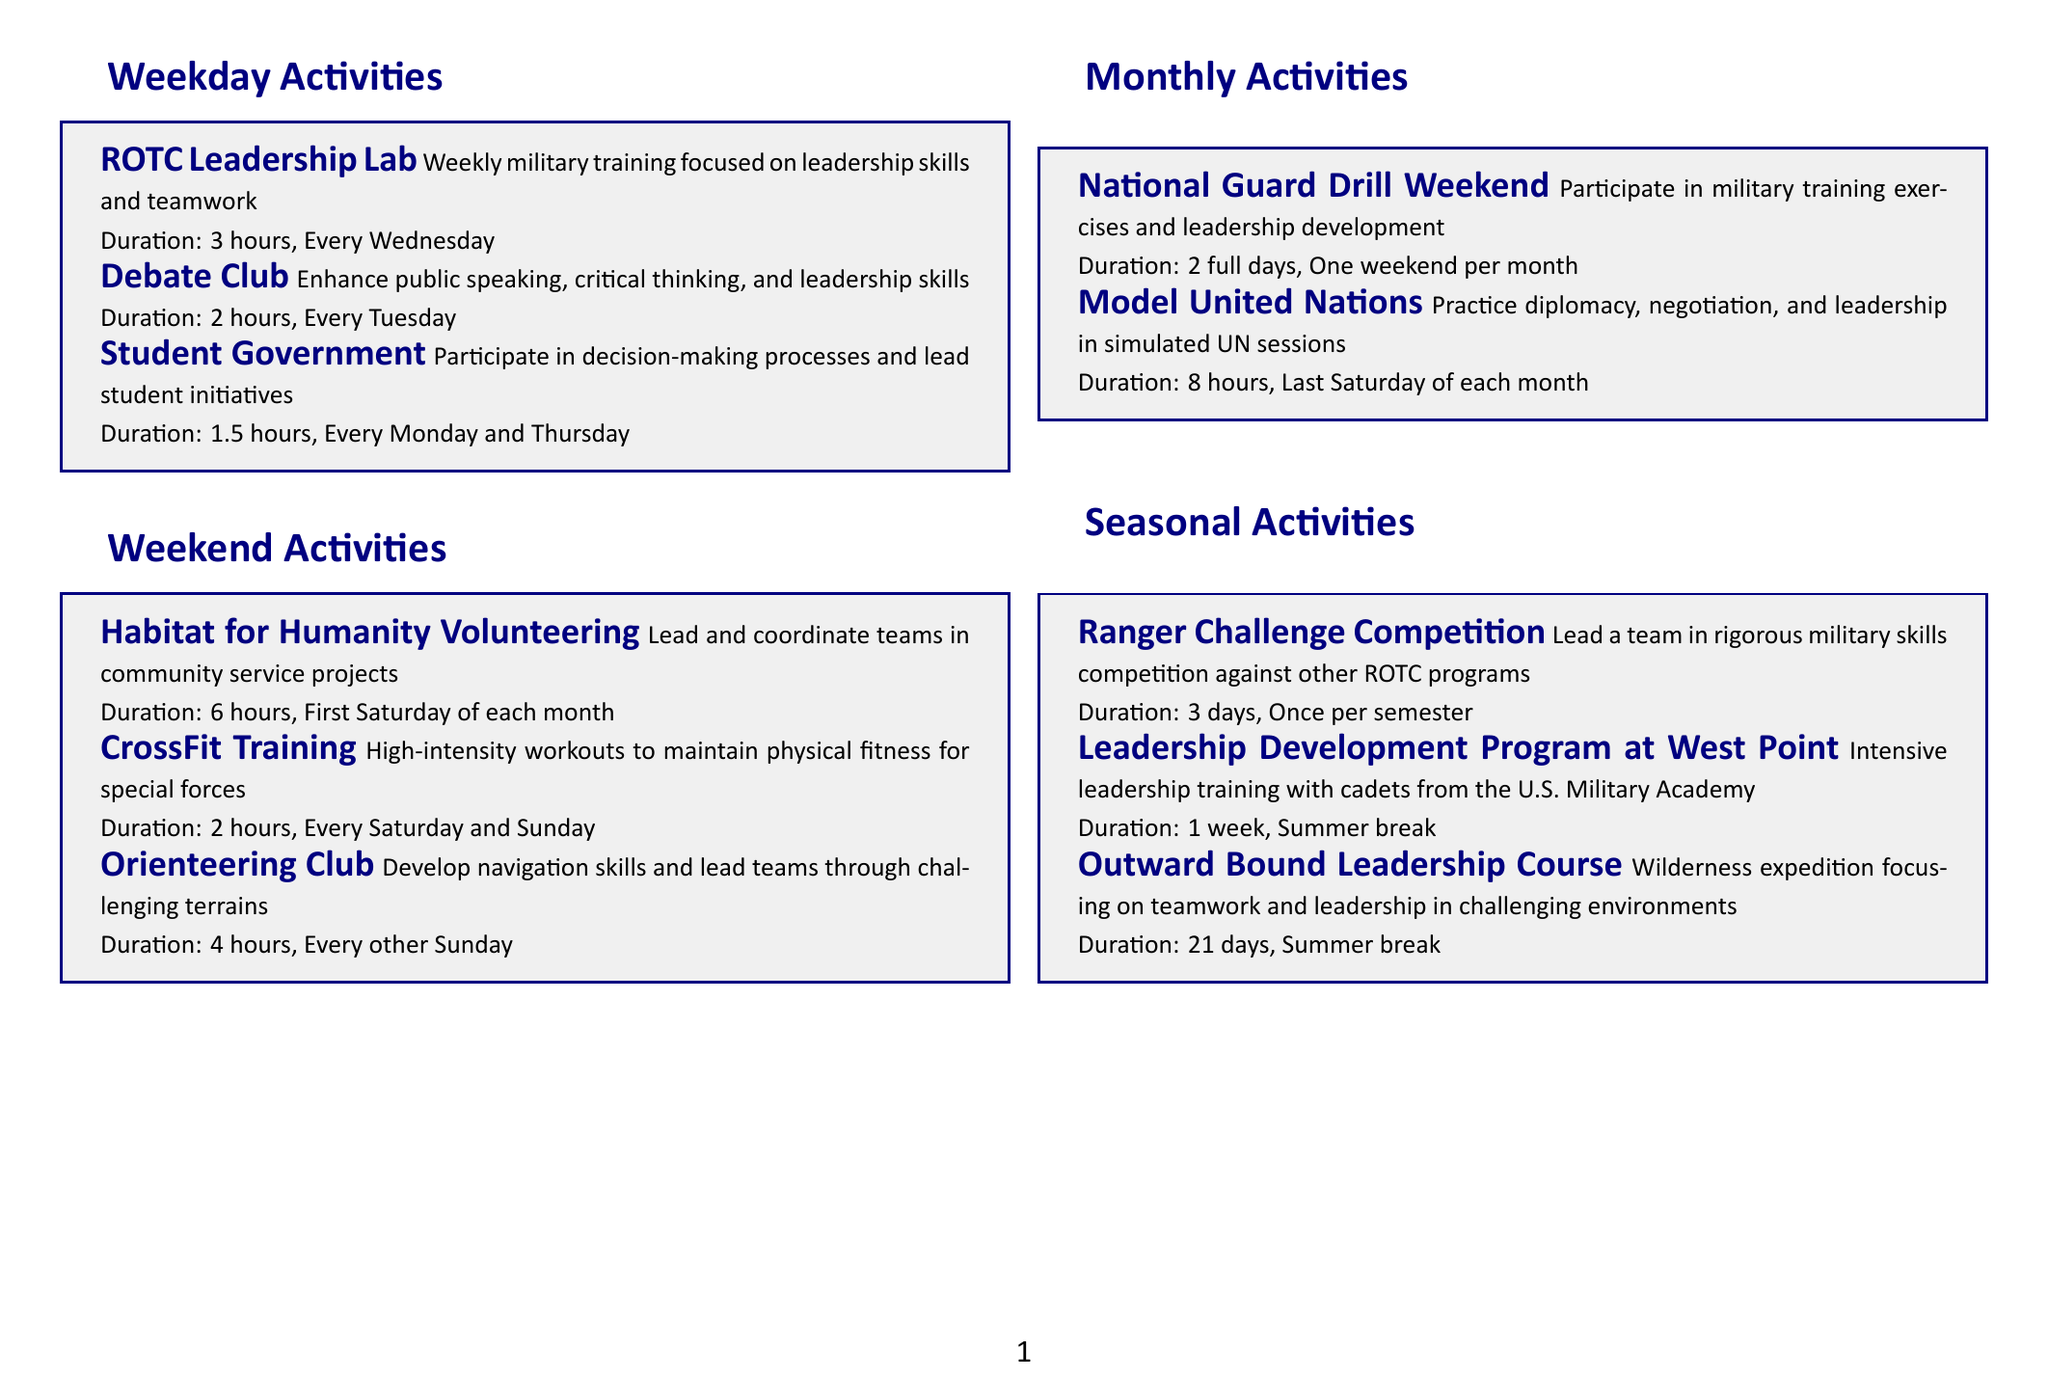What is the duration of the ROTC Leadership Lab? The duration is explicitly stated in the document as 3 hours.
Answer: 3 hours How often is the Debate Club held? The document specifies the frequency of the Debate Club as every Tuesday.
Answer: Every Tuesday What activity focuses on community service projects? The document lists "Habitat for Humanity Volunteering" as the activity focusing on community service.
Answer: Habitat for Humanity Volunteering What is the frequency of the Ranger Challenge Competition? The document states that the Ranger Challenge Competition occurs once per semester.
Answer: Once per semester How long does the Leadership Development Program at West Point last? The document provides the duration of the Leadership Development Program as 1 week.
Answer: 1 week What skill does the Orienteering Club develop? The document mentions that the Orienteering Club develops navigation skills.
Answer: Navigation skills Which activity is held on the last Saturday of each month? The document identifies "Model United Nations" as the activity occurring on the last Saturday of each month.
Answer: Model United Nations What is the duration of the National Guard Drill Weekend? The duration is stated in the document as 2 full days.
Answer: 2 full days How many hours is CrossFit Training scheduled for? The document specifies the duration of CrossFit Training as 2 hours.
Answer: 2 hours 